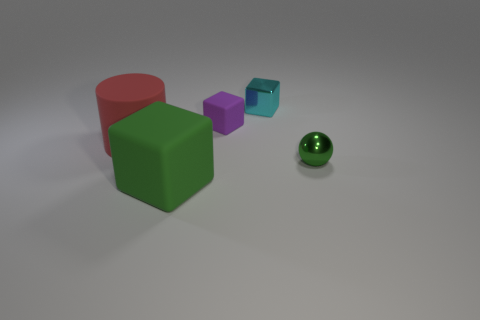Are there any metallic blocks that are on the left side of the metallic thing that is behind the purple rubber thing?
Offer a very short reply. No. How many big objects are there?
Provide a succinct answer. 2. There is a large block; does it have the same color as the small cube that is in front of the metallic cube?
Ensure brevity in your answer.  No. Is the number of red objects greater than the number of big red shiny blocks?
Offer a terse response. Yes. Is there anything else that has the same color as the tiny rubber cube?
Your answer should be very brief. No. What number of other things are the same size as the sphere?
Your response must be concise. 2. What material is the big object in front of the big object to the left of the big green block on the right side of the large cylinder?
Your response must be concise. Rubber. Is the material of the small cyan cube the same as the large object that is behind the big green cube?
Provide a succinct answer. No. Is the number of green matte blocks behind the purple rubber block less than the number of balls that are in front of the large red matte object?
Your response must be concise. Yes. What number of large red objects are the same material as the small purple thing?
Offer a very short reply. 1. 